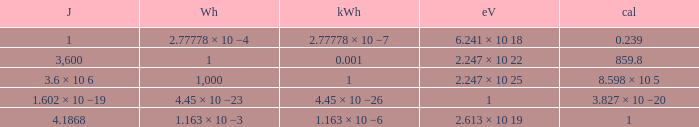How many calories is 1 watt hour? 859.8. 